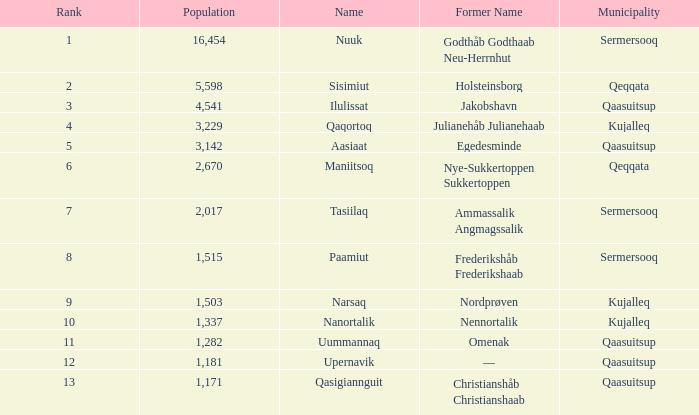Who has a former name of nordprøven? Narsaq. 